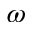Convert formula to latex. <formula><loc_0><loc_0><loc_500><loc_500>\omega</formula> 